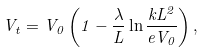Convert formula to latex. <formula><loc_0><loc_0><loc_500><loc_500>V _ { t } = V _ { 0 } \left ( 1 - \frac { \lambda } { L } \ln \frac { k L ^ { 2 } } { e V _ { 0 } } \right ) ,</formula> 